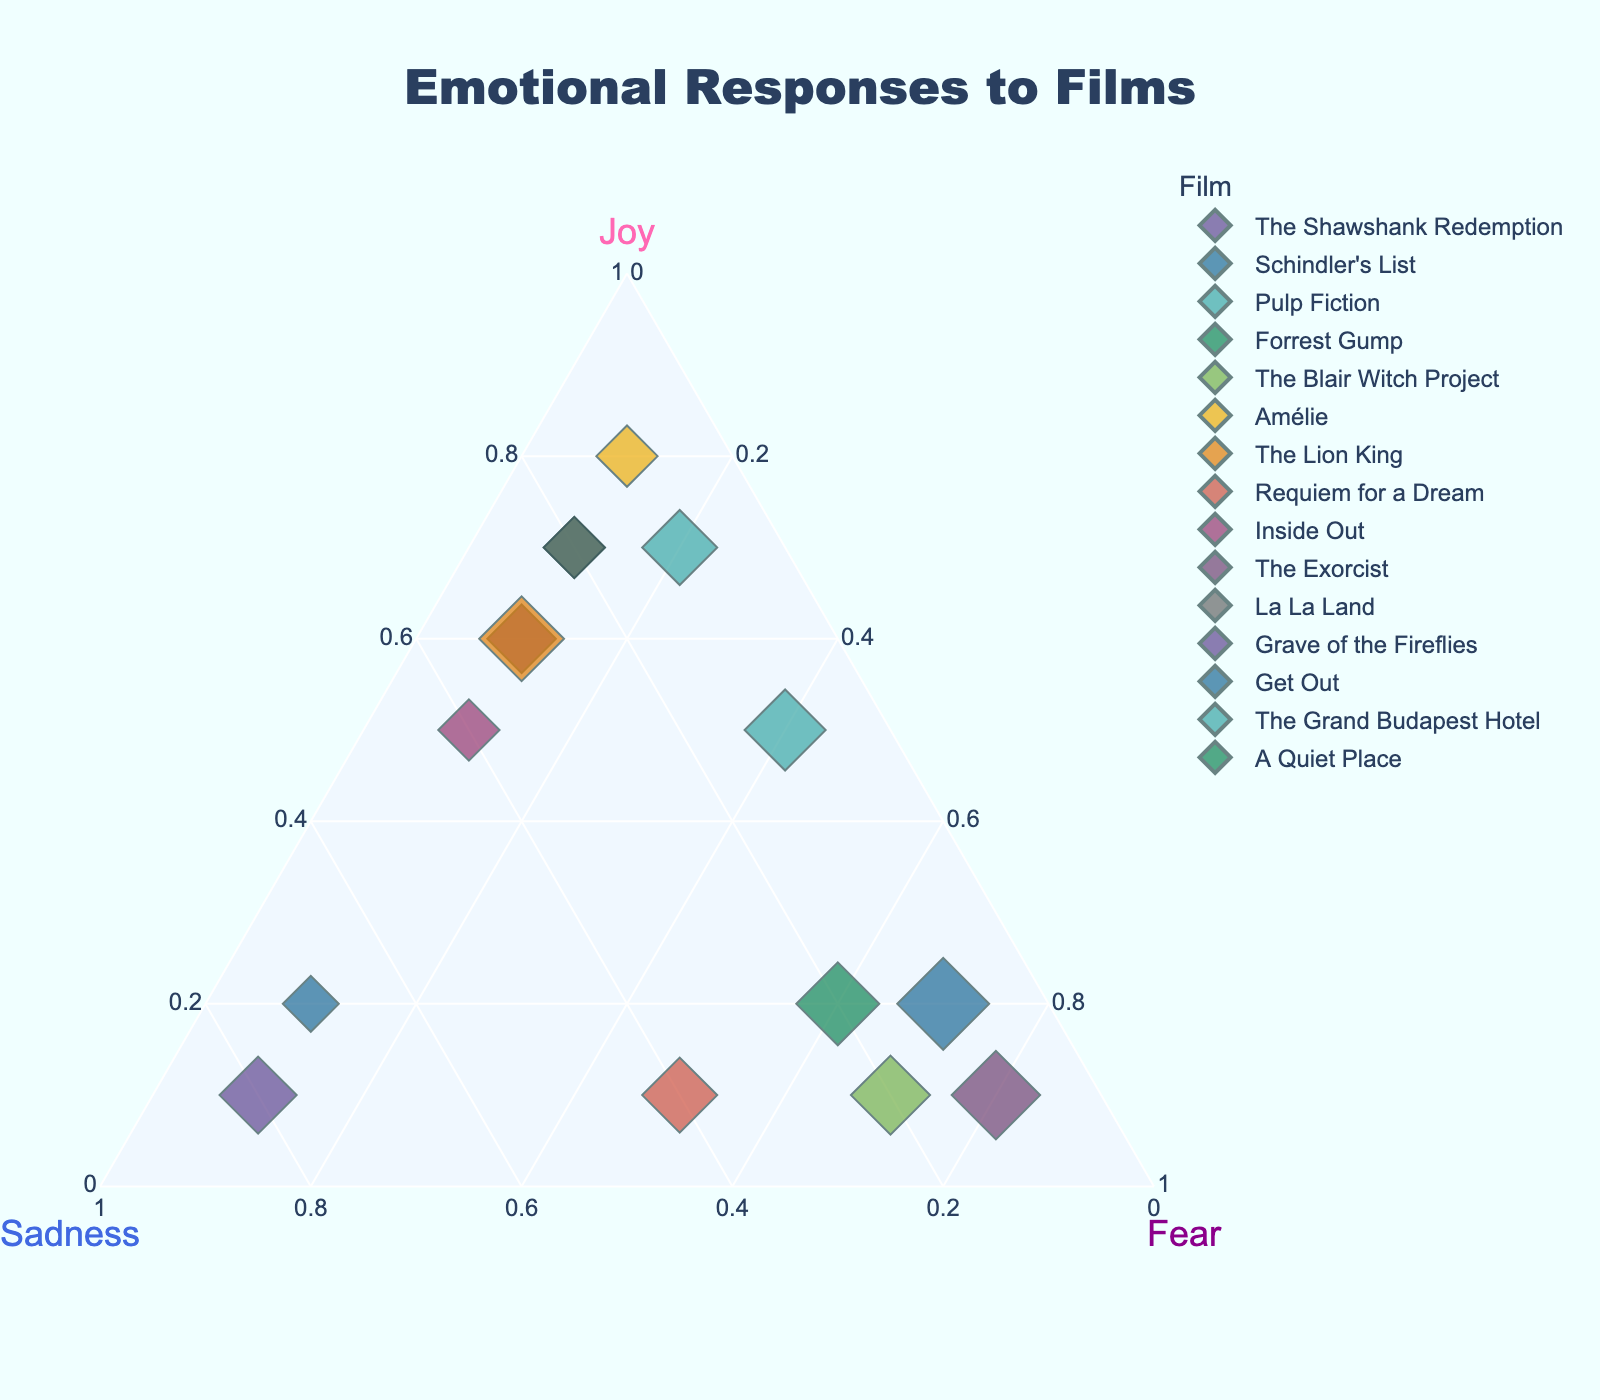what is the title of the plot? The title is located at the top center of the figure. By looking at that location, we can see the title displayed.
Answer: Emotional Responses to Films what colors represent "Joy", "Sadness", and "Fear" axes? By examining the labels and their respective colors at the vertices of the triangle, we see that "Joy" is pink, "Sadness" is blue, and "Fear" is purple.
Answer: Pink, Blue, Purple which film has the highest ratio of feelings of joy? Looking at the vertex labeled "Joy," the data point closest to it represents the film with the highest joy ratio. This data point is "Amélie."
Answer: Amélie which films equate to the least ratio of fear? By identifying the data points closest to the opposite side of the "Fear" vertex, we can see that "The Shawshank Redemption," "Forrest Gump," "Amélie," "The Lion King," "La La Land," and "Grave of the Fireflies" are equally close to the opposite side of the "Fear" vertex.
Answer: The Shawshank Redemption, Forrest Gump, Amélie, The Lion King, La La Land, Grave of the Fireflies what's a common emotional ratio shared among "Schindler's List" and "Grave of the Fireflies"? Comparing the locations of "Schindler's List" and "Grave of the Fireflies," we see both align closer to the "Sadness" vertex.
Answer: High sadness ratio how is "The Exorcist" different from other films? "The Exorcist" is positioned closest to the "Fear" vertex, indicating it elicits a much stronger fear response compared to other films.
Answer: Elicits strongest fear response compare the emotional responses between "Pulp Fiction" and "Requiem for a Dream"? We see that "Pulp Fiction" shows a balance between joy and fear, while "Requiem for a Dream" has significant fear but much less joy and an intermediate sadness ratio.
Answer: Pulp Fiction: balanced joy and fear, Requiem for a Dream: high fear, intermediate sadness, low joy which film stands between "Amélie" and "Inside Out" in terms of emotional ratios? By observing the positions, we find that "La La Land" and "Forrest Gump" lie almost between "Amélie" and "Inside Out" with similar emotional responses in joy and lower sadness ratio.
Answer: La La Land, Forrest Gump if a film generates 0.2 joy, 0.1 sadness, and 0.7 fear, how would it align with the films in the plot? By adding up the coordinates and checking for a similar ratio, we find that these values match the emotional map of "Get Out."
Answer: Get Out, A Quiet Place 